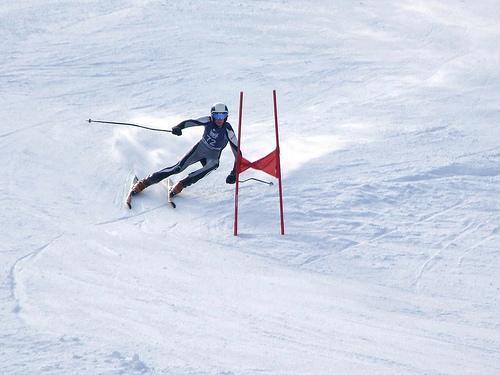How many people are in the photo?
Give a very brief answer. 1. 